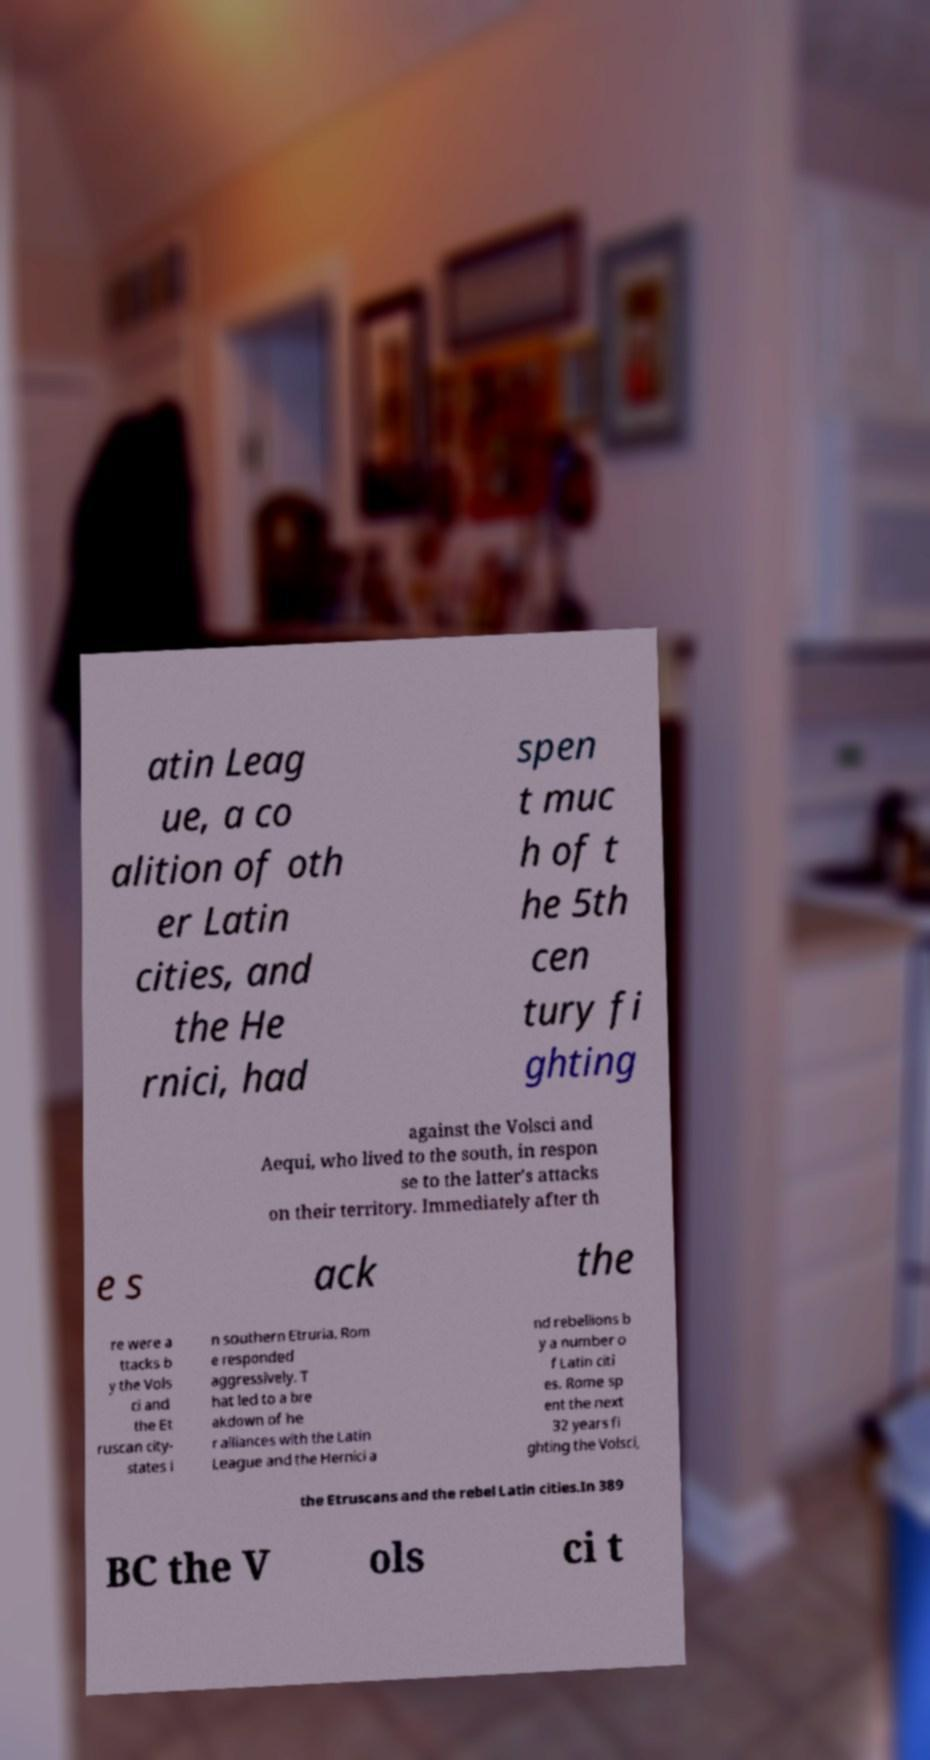What messages or text are displayed in this image? I need them in a readable, typed format. atin Leag ue, a co alition of oth er Latin cities, and the He rnici, had spen t muc h of t he 5th cen tury fi ghting against the Volsci and Aequi, who lived to the south, in respon se to the latter's attacks on their territory. Immediately after th e s ack the re were a ttacks b y the Vols ci and the Et ruscan city- states i n southern Etruria. Rom e responded aggressively. T hat led to a bre akdown of he r alliances with the Latin League and the Hernici a nd rebellions b y a number o f Latin citi es. Rome sp ent the next 32 years fi ghting the Volsci, the Etruscans and the rebel Latin cities.In 389 BC the V ols ci t 